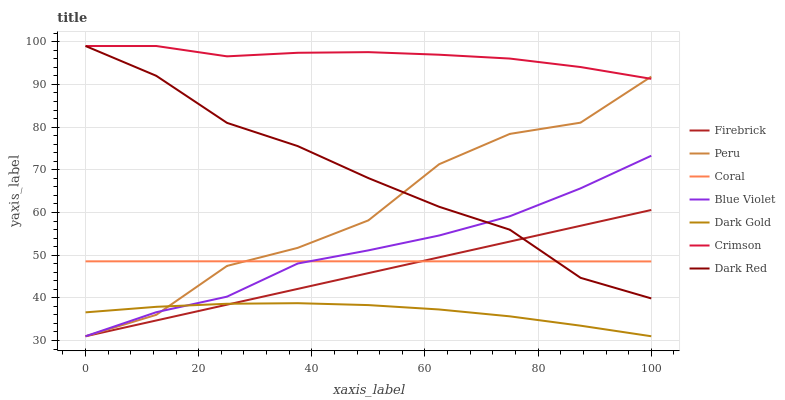Does Dark Gold have the minimum area under the curve?
Answer yes or no. Yes. Does Crimson have the maximum area under the curve?
Answer yes or no. Yes. Does Dark Red have the minimum area under the curve?
Answer yes or no. No. Does Dark Red have the maximum area under the curve?
Answer yes or no. No. Is Firebrick the smoothest?
Answer yes or no. Yes. Is Peru the roughest?
Answer yes or no. Yes. Is Dark Red the smoothest?
Answer yes or no. No. Is Dark Red the roughest?
Answer yes or no. No. Does Dark Gold have the lowest value?
Answer yes or no. Yes. Does Dark Red have the lowest value?
Answer yes or no. No. Does Crimson have the highest value?
Answer yes or no. Yes. Does Firebrick have the highest value?
Answer yes or no. No. Is Blue Violet less than Crimson?
Answer yes or no. Yes. Is Dark Red greater than Dark Gold?
Answer yes or no. Yes. Does Firebrick intersect Dark Red?
Answer yes or no. Yes. Is Firebrick less than Dark Red?
Answer yes or no. No. Is Firebrick greater than Dark Red?
Answer yes or no. No. Does Blue Violet intersect Crimson?
Answer yes or no. No. 